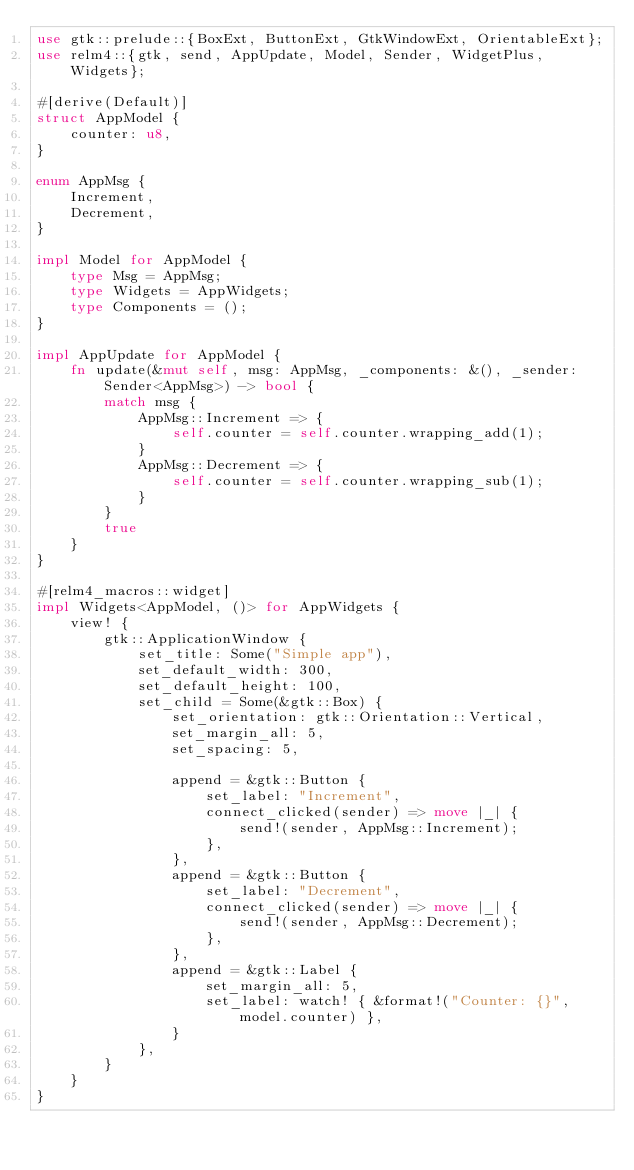<code> <loc_0><loc_0><loc_500><loc_500><_Rust_>use gtk::prelude::{BoxExt, ButtonExt, GtkWindowExt, OrientableExt};
use relm4::{gtk, send, AppUpdate, Model, Sender, WidgetPlus, Widgets};

#[derive(Default)]
struct AppModel {
    counter: u8,
}

enum AppMsg {
    Increment,
    Decrement,
}

impl Model for AppModel {
    type Msg = AppMsg;
    type Widgets = AppWidgets;
    type Components = ();
}

impl AppUpdate for AppModel {
    fn update(&mut self, msg: AppMsg, _components: &(), _sender: Sender<AppMsg>) -> bool {
        match msg {
            AppMsg::Increment => {
                self.counter = self.counter.wrapping_add(1);
            }
            AppMsg::Decrement => {
                self.counter = self.counter.wrapping_sub(1);
            }
        }
        true
    }
}

#[relm4_macros::widget]
impl Widgets<AppModel, ()> for AppWidgets {
    view! {
        gtk::ApplicationWindow {
            set_title: Some("Simple app"),
            set_default_width: 300,
            set_default_height: 100,
            set_child = Some(&gtk::Box) {
                set_orientation: gtk::Orientation::Vertical,
                set_margin_all: 5,
                set_spacing: 5,

                append = &gtk::Button {
                    set_label: "Increment",
                    connect_clicked(sender) => move |_| {
                        send!(sender, AppMsg::Increment);
                    },
                },
                append = &gtk::Button {
                    set_label: "Decrement",
                    connect_clicked(sender) => move |_| {
                        send!(sender, AppMsg::Decrement);
                    },
                },
                append = &gtk::Label {
                    set_margin_all: 5,
                    set_label: watch! { &format!("Counter: {}", model.counter) },
                }
            },
        }
    }
}
</code> 